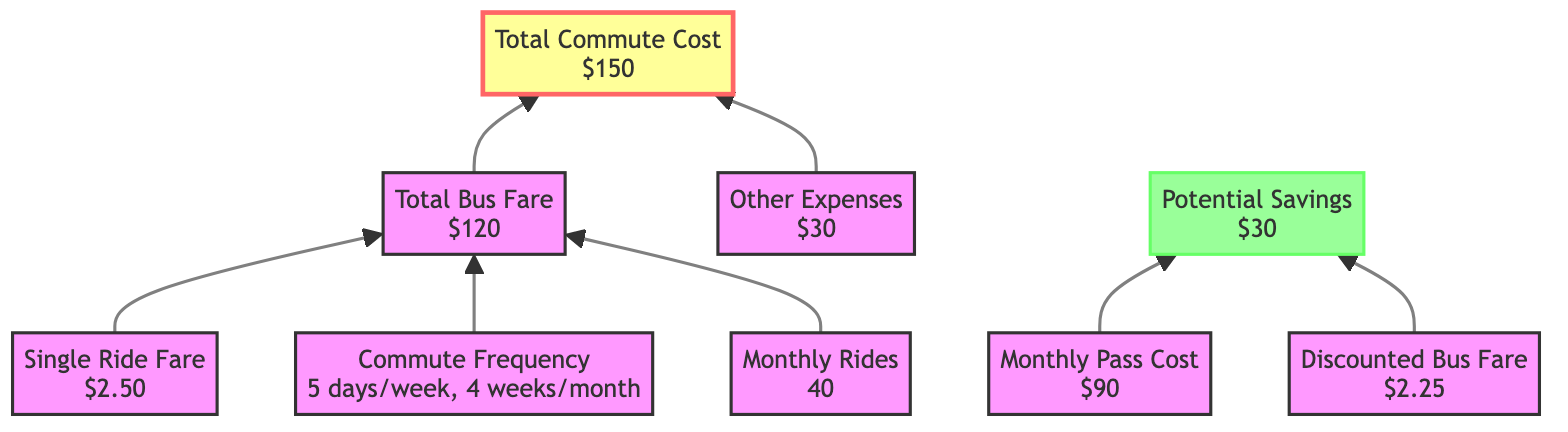What is the value of the Single Ride Fare? The Single Ride Fare is explicitly stated in the diagram as $2.50.
Answer: $2.50 How many days per week does the commuter travel? The diagram shows that the commute frequency is 5 days per week.
Answer: 5 days What is the Monthly Pass Cost? The diagram indicates that the Monthly Pass Cost is $90.
Answer: $90 How many Monthly Rides does the commuter take? The Monthly Rides node states that the value is 40 rides per month.
Answer: 40 What is the Total Commute Cost? The Total Commute Cost is highlighted in the diagram and is $150.
Answer: $150 What are the potential savings from discounts? According to the diagram, the potential savings from discounts are $30.
Answer: $30 How is the Total Bus Fare calculated? The Total Bus Fare is derived from the Single Ride Fare multiplied by the Monthly Rides (2.50 * 40), resulting in $120.
Answer: $120 What is the relationship between Monthly Pass Cost and Potential Savings? The diagram shows that the Monthly Pass Cost leads to Potential Savings, indicating that the use of the pass results in savings when compared to paying the full bus fare.
Answer: Monthly Pass Cost leads to Potential Savings In which layer of the diagram does the Total Commute Cost reside? The Total Commute Cost appears at a higher layer of the diagram, as it sums up the components from the lower layers such as Total Bus Fare and Other Expenses.
Answer: Higher layer 